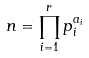Convert formula to latex. <formula><loc_0><loc_0><loc_500><loc_500>n = \prod _ { i = 1 } ^ { r } p _ { i } ^ { a _ { i } }</formula> 